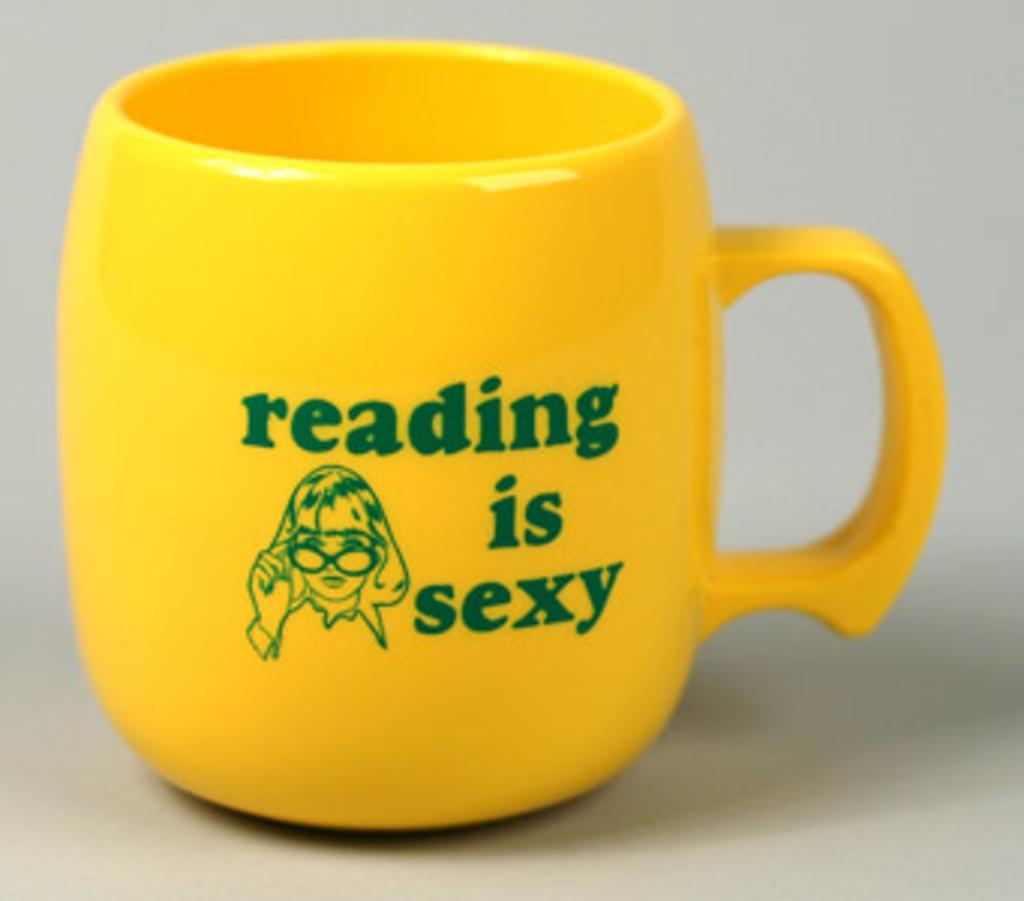What object is present in the picture? There is a cup in the picture. What message is written on the cup? The cup has writing on it that says "reading is sexy." What type of pickle is being served in the cup? There is no pickle present in the image; it is a cup with writing on it. What is the governor's opinion on the message written on the cup? The image does not provide any information about the governor's opinion, as it only shows a cup with writing on it. 